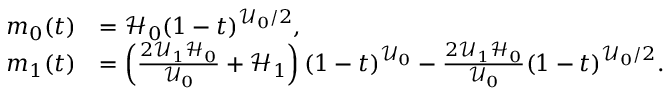Convert formula to latex. <formula><loc_0><loc_0><loc_500><loc_500>\begin{array} { r l } { m _ { 0 } ( t ) } & { = \mathcal { H } _ { 0 } ( 1 - t ) ^ { \mathcal { U } _ { 0 } / 2 } , } \\ { m _ { 1 } ( t ) } & { = \left ( \frac { 2 \mathcal { U } _ { 1 } \mathcal { H } _ { 0 } } { \mathcal { U } _ { 0 } } + \mathcal { H } _ { 1 } \right ) ( 1 - t ) ^ { \mathcal { U } _ { 0 } } - \frac { 2 \mathcal { U } _ { 1 } \mathcal { H } _ { 0 } } { \mathcal { U } _ { 0 } } ( 1 - t ) ^ { \mathcal { U } _ { 0 } / 2 } . } \end{array}</formula> 